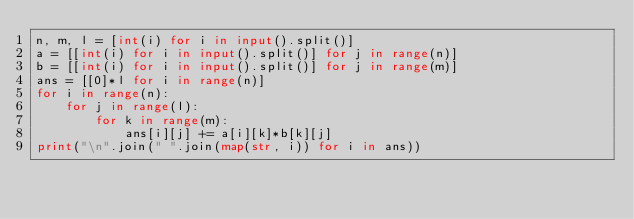<code> <loc_0><loc_0><loc_500><loc_500><_Python_>n, m, l = [int(i) for i in input().split()]
a = [[int(i) for i in input().split()] for j in range(n)]
b = [[int(i) for i in input().split()] for j in range(m)]
ans = [[0]*l for i in range(n)]
for i in range(n):
    for j in range(l):
        for k in range(m):
            ans[i][j] += a[i][k]*b[k][j]
print("\n".join(" ".join(map(str, i)) for i in ans))
</code> 